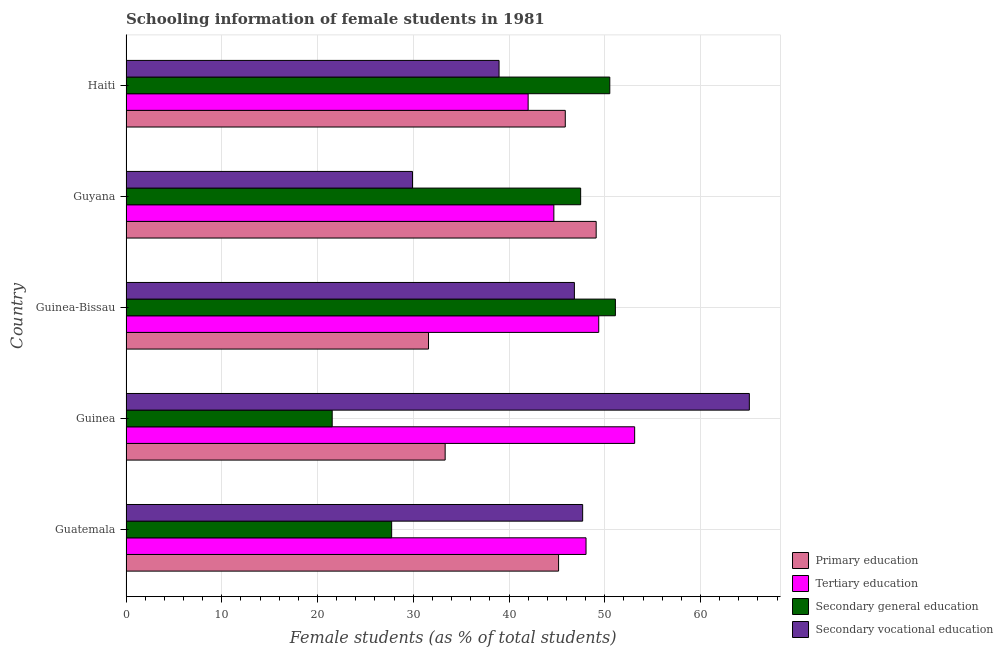How many groups of bars are there?
Provide a succinct answer. 5. Are the number of bars per tick equal to the number of legend labels?
Give a very brief answer. Yes. What is the label of the 5th group of bars from the top?
Provide a short and direct response. Guatemala. In how many cases, is the number of bars for a given country not equal to the number of legend labels?
Ensure brevity in your answer.  0. What is the percentage of female students in secondary education in Guinea-Bissau?
Your answer should be compact. 51.11. Across all countries, what is the maximum percentage of female students in primary education?
Make the answer very short. 49.1. Across all countries, what is the minimum percentage of female students in secondary education?
Provide a short and direct response. 21.53. In which country was the percentage of female students in tertiary education maximum?
Your answer should be compact. Guinea. In which country was the percentage of female students in secondary education minimum?
Your answer should be very brief. Guinea. What is the total percentage of female students in secondary vocational education in the graph?
Your response must be concise. 228.5. What is the difference between the percentage of female students in tertiary education in Guinea and that in Haiti?
Ensure brevity in your answer.  11.12. What is the difference between the percentage of female students in secondary vocational education in Guatemala and the percentage of female students in secondary education in Guinea?
Your response must be concise. 26.16. What is the average percentage of female students in secondary education per country?
Offer a very short reply. 39.68. What is the difference between the percentage of female students in secondary vocational education and percentage of female students in tertiary education in Guinea?
Offer a terse response. 11.98. What is the ratio of the percentage of female students in secondary vocational education in Guatemala to that in Haiti?
Provide a succinct answer. 1.22. Is the percentage of female students in secondary education in Guatemala less than that in Guinea-Bissau?
Give a very brief answer. Yes. What is the difference between the highest and the second highest percentage of female students in secondary vocational education?
Your answer should be very brief. 17.41. What is the difference between the highest and the lowest percentage of female students in tertiary education?
Provide a short and direct response. 11.13. Is it the case that in every country, the sum of the percentage of female students in secondary education and percentage of female students in primary education is greater than the sum of percentage of female students in secondary vocational education and percentage of female students in tertiary education?
Ensure brevity in your answer.  No. What does the 2nd bar from the top in Guatemala represents?
Offer a terse response. Secondary general education. What does the 4th bar from the bottom in Guatemala represents?
Your answer should be compact. Secondary vocational education. How many bars are there?
Offer a terse response. 20. Are the values on the major ticks of X-axis written in scientific E-notation?
Your response must be concise. No. Where does the legend appear in the graph?
Offer a terse response. Bottom right. How are the legend labels stacked?
Your answer should be very brief. Vertical. What is the title of the graph?
Provide a short and direct response. Schooling information of female students in 1981. What is the label or title of the X-axis?
Keep it short and to the point. Female students (as % of total students). What is the Female students (as % of total students) of Primary education in Guatemala?
Provide a succinct answer. 45.18. What is the Female students (as % of total students) in Tertiary education in Guatemala?
Offer a very short reply. 48.04. What is the Female students (as % of total students) of Secondary general education in Guatemala?
Ensure brevity in your answer.  27.74. What is the Female students (as % of total students) in Secondary vocational education in Guatemala?
Make the answer very short. 47.69. What is the Female students (as % of total students) of Primary education in Guinea?
Your response must be concise. 33.33. What is the Female students (as % of total students) of Tertiary education in Guinea?
Give a very brief answer. 53.12. What is the Female students (as % of total students) of Secondary general education in Guinea?
Your answer should be compact. 21.53. What is the Female students (as % of total students) in Secondary vocational education in Guinea?
Give a very brief answer. 65.1. What is the Female students (as % of total students) in Primary education in Guinea-Bissau?
Offer a terse response. 31.59. What is the Female students (as % of total students) of Tertiary education in Guinea-Bissau?
Offer a very short reply. 49.37. What is the Female students (as % of total students) of Secondary general education in Guinea-Bissau?
Offer a very short reply. 51.11. What is the Female students (as % of total students) of Secondary vocational education in Guinea-Bissau?
Keep it short and to the point. 46.83. What is the Female students (as % of total students) of Primary education in Guyana?
Give a very brief answer. 49.1. What is the Female students (as % of total students) of Tertiary education in Guyana?
Ensure brevity in your answer.  44.68. What is the Female students (as % of total students) of Secondary general education in Guyana?
Keep it short and to the point. 47.48. What is the Female students (as % of total students) of Secondary vocational education in Guyana?
Your answer should be compact. 29.92. What is the Female students (as % of total students) of Primary education in Haiti?
Make the answer very short. 45.88. What is the Female students (as % of total students) in Tertiary education in Haiti?
Your response must be concise. 42. What is the Female students (as % of total students) of Secondary general education in Haiti?
Offer a very short reply. 50.53. What is the Female students (as % of total students) in Secondary vocational education in Haiti?
Your answer should be very brief. 38.96. Across all countries, what is the maximum Female students (as % of total students) of Primary education?
Your response must be concise. 49.1. Across all countries, what is the maximum Female students (as % of total students) in Tertiary education?
Your response must be concise. 53.12. Across all countries, what is the maximum Female students (as % of total students) in Secondary general education?
Your answer should be compact. 51.11. Across all countries, what is the maximum Female students (as % of total students) in Secondary vocational education?
Your answer should be very brief. 65.1. Across all countries, what is the minimum Female students (as % of total students) of Primary education?
Make the answer very short. 31.59. Across all countries, what is the minimum Female students (as % of total students) of Tertiary education?
Your answer should be very brief. 42. Across all countries, what is the minimum Female students (as % of total students) of Secondary general education?
Give a very brief answer. 21.53. Across all countries, what is the minimum Female students (as % of total students) of Secondary vocational education?
Provide a succinct answer. 29.92. What is the total Female students (as % of total students) in Primary education in the graph?
Your response must be concise. 205.08. What is the total Female students (as % of total students) of Tertiary education in the graph?
Your answer should be very brief. 237.22. What is the total Female students (as % of total students) in Secondary general education in the graph?
Your answer should be very brief. 198.4. What is the total Female students (as % of total students) in Secondary vocational education in the graph?
Your answer should be compact. 228.5. What is the difference between the Female students (as % of total students) in Primary education in Guatemala and that in Guinea?
Provide a succinct answer. 11.85. What is the difference between the Female students (as % of total students) in Tertiary education in Guatemala and that in Guinea?
Give a very brief answer. -5.08. What is the difference between the Female students (as % of total students) in Secondary general education in Guatemala and that in Guinea?
Make the answer very short. 6.21. What is the difference between the Female students (as % of total students) in Secondary vocational education in Guatemala and that in Guinea?
Give a very brief answer. -17.41. What is the difference between the Female students (as % of total students) of Primary education in Guatemala and that in Guinea-Bissau?
Give a very brief answer. 13.58. What is the difference between the Female students (as % of total students) in Tertiary education in Guatemala and that in Guinea-Bissau?
Offer a terse response. -1.33. What is the difference between the Female students (as % of total students) in Secondary general education in Guatemala and that in Guinea-Bissau?
Make the answer very short. -23.37. What is the difference between the Female students (as % of total students) of Secondary vocational education in Guatemala and that in Guinea-Bissau?
Provide a succinct answer. 0.86. What is the difference between the Female students (as % of total students) of Primary education in Guatemala and that in Guyana?
Ensure brevity in your answer.  -3.93. What is the difference between the Female students (as % of total students) of Tertiary education in Guatemala and that in Guyana?
Provide a short and direct response. 3.36. What is the difference between the Female students (as % of total students) of Secondary general education in Guatemala and that in Guyana?
Ensure brevity in your answer.  -19.74. What is the difference between the Female students (as % of total students) of Secondary vocational education in Guatemala and that in Guyana?
Your response must be concise. 17.77. What is the difference between the Female students (as % of total students) of Primary education in Guatemala and that in Haiti?
Offer a very short reply. -0.7. What is the difference between the Female students (as % of total students) of Tertiary education in Guatemala and that in Haiti?
Provide a short and direct response. 6.05. What is the difference between the Female students (as % of total students) in Secondary general education in Guatemala and that in Haiti?
Provide a succinct answer. -22.78. What is the difference between the Female students (as % of total students) of Secondary vocational education in Guatemala and that in Haiti?
Your answer should be compact. 8.73. What is the difference between the Female students (as % of total students) of Primary education in Guinea and that in Guinea-Bissau?
Offer a terse response. 1.74. What is the difference between the Female students (as % of total students) in Tertiary education in Guinea and that in Guinea-Bissau?
Provide a short and direct response. 3.75. What is the difference between the Female students (as % of total students) in Secondary general education in Guinea and that in Guinea-Bissau?
Ensure brevity in your answer.  -29.58. What is the difference between the Female students (as % of total students) in Secondary vocational education in Guinea and that in Guinea-Bissau?
Offer a terse response. 18.27. What is the difference between the Female students (as % of total students) in Primary education in Guinea and that in Guyana?
Your response must be concise. -15.77. What is the difference between the Female students (as % of total students) in Tertiary education in Guinea and that in Guyana?
Offer a terse response. 8.44. What is the difference between the Female students (as % of total students) of Secondary general education in Guinea and that in Guyana?
Provide a succinct answer. -25.95. What is the difference between the Female students (as % of total students) of Secondary vocational education in Guinea and that in Guyana?
Keep it short and to the point. 35.18. What is the difference between the Female students (as % of total students) in Primary education in Guinea and that in Haiti?
Make the answer very short. -12.55. What is the difference between the Female students (as % of total students) of Tertiary education in Guinea and that in Haiti?
Provide a short and direct response. 11.12. What is the difference between the Female students (as % of total students) in Secondary general education in Guinea and that in Haiti?
Give a very brief answer. -28.99. What is the difference between the Female students (as % of total students) of Secondary vocational education in Guinea and that in Haiti?
Your answer should be very brief. 26.14. What is the difference between the Female students (as % of total students) of Primary education in Guinea-Bissau and that in Guyana?
Give a very brief answer. -17.51. What is the difference between the Female students (as % of total students) of Tertiary education in Guinea-Bissau and that in Guyana?
Provide a succinct answer. 4.69. What is the difference between the Female students (as % of total students) of Secondary general education in Guinea-Bissau and that in Guyana?
Provide a short and direct response. 3.63. What is the difference between the Female students (as % of total students) in Secondary vocational education in Guinea-Bissau and that in Guyana?
Give a very brief answer. 16.91. What is the difference between the Female students (as % of total students) in Primary education in Guinea-Bissau and that in Haiti?
Offer a terse response. -14.28. What is the difference between the Female students (as % of total students) of Tertiary education in Guinea-Bissau and that in Haiti?
Make the answer very short. 7.37. What is the difference between the Female students (as % of total students) in Secondary general education in Guinea-Bissau and that in Haiti?
Make the answer very short. 0.58. What is the difference between the Female students (as % of total students) in Secondary vocational education in Guinea-Bissau and that in Haiti?
Your answer should be very brief. 7.87. What is the difference between the Female students (as % of total students) in Primary education in Guyana and that in Haiti?
Ensure brevity in your answer.  3.23. What is the difference between the Female students (as % of total students) of Tertiary education in Guyana and that in Haiti?
Provide a short and direct response. 2.69. What is the difference between the Female students (as % of total students) of Secondary general education in Guyana and that in Haiti?
Give a very brief answer. -3.04. What is the difference between the Female students (as % of total students) in Secondary vocational education in Guyana and that in Haiti?
Make the answer very short. -9.04. What is the difference between the Female students (as % of total students) in Primary education in Guatemala and the Female students (as % of total students) in Tertiary education in Guinea?
Give a very brief answer. -7.95. What is the difference between the Female students (as % of total students) in Primary education in Guatemala and the Female students (as % of total students) in Secondary general education in Guinea?
Keep it short and to the point. 23.64. What is the difference between the Female students (as % of total students) of Primary education in Guatemala and the Female students (as % of total students) of Secondary vocational education in Guinea?
Offer a very short reply. -19.92. What is the difference between the Female students (as % of total students) in Tertiary education in Guatemala and the Female students (as % of total students) in Secondary general education in Guinea?
Provide a short and direct response. 26.51. What is the difference between the Female students (as % of total students) in Tertiary education in Guatemala and the Female students (as % of total students) in Secondary vocational education in Guinea?
Your answer should be very brief. -17.06. What is the difference between the Female students (as % of total students) of Secondary general education in Guatemala and the Female students (as % of total students) of Secondary vocational education in Guinea?
Your answer should be compact. -37.36. What is the difference between the Female students (as % of total students) in Primary education in Guatemala and the Female students (as % of total students) in Tertiary education in Guinea-Bissau?
Offer a terse response. -4.19. What is the difference between the Female students (as % of total students) of Primary education in Guatemala and the Female students (as % of total students) of Secondary general education in Guinea-Bissau?
Your response must be concise. -5.93. What is the difference between the Female students (as % of total students) of Primary education in Guatemala and the Female students (as % of total students) of Secondary vocational education in Guinea-Bissau?
Give a very brief answer. -1.65. What is the difference between the Female students (as % of total students) of Tertiary education in Guatemala and the Female students (as % of total students) of Secondary general education in Guinea-Bissau?
Your response must be concise. -3.07. What is the difference between the Female students (as % of total students) of Tertiary education in Guatemala and the Female students (as % of total students) of Secondary vocational education in Guinea-Bissau?
Keep it short and to the point. 1.22. What is the difference between the Female students (as % of total students) of Secondary general education in Guatemala and the Female students (as % of total students) of Secondary vocational education in Guinea-Bissau?
Keep it short and to the point. -19.08. What is the difference between the Female students (as % of total students) in Primary education in Guatemala and the Female students (as % of total students) in Tertiary education in Guyana?
Offer a terse response. 0.49. What is the difference between the Female students (as % of total students) of Primary education in Guatemala and the Female students (as % of total students) of Secondary general education in Guyana?
Your answer should be compact. -2.31. What is the difference between the Female students (as % of total students) in Primary education in Guatemala and the Female students (as % of total students) in Secondary vocational education in Guyana?
Ensure brevity in your answer.  15.26. What is the difference between the Female students (as % of total students) of Tertiary education in Guatemala and the Female students (as % of total students) of Secondary general education in Guyana?
Your response must be concise. 0.56. What is the difference between the Female students (as % of total students) of Tertiary education in Guatemala and the Female students (as % of total students) of Secondary vocational education in Guyana?
Your answer should be very brief. 18.12. What is the difference between the Female students (as % of total students) in Secondary general education in Guatemala and the Female students (as % of total students) in Secondary vocational education in Guyana?
Keep it short and to the point. -2.18. What is the difference between the Female students (as % of total students) of Primary education in Guatemala and the Female students (as % of total students) of Tertiary education in Haiti?
Offer a very short reply. 3.18. What is the difference between the Female students (as % of total students) of Primary education in Guatemala and the Female students (as % of total students) of Secondary general education in Haiti?
Your answer should be very brief. -5.35. What is the difference between the Female students (as % of total students) in Primary education in Guatemala and the Female students (as % of total students) in Secondary vocational education in Haiti?
Keep it short and to the point. 6.21. What is the difference between the Female students (as % of total students) in Tertiary education in Guatemala and the Female students (as % of total students) in Secondary general education in Haiti?
Give a very brief answer. -2.48. What is the difference between the Female students (as % of total students) in Tertiary education in Guatemala and the Female students (as % of total students) in Secondary vocational education in Haiti?
Your response must be concise. 9.08. What is the difference between the Female students (as % of total students) in Secondary general education in Guatemala and the Female students (as % of total students) in Secondary vocational education in Haiti?
Your answer should be compact. -11.22. What is the difference between the Female students (as % of total students) of Primary education in Guinea and the Female students (as % of total students) of Tertiary education in Guinea-Bissau?
Provide a succinct answer. -16.04. What is the difference between the Female students (as % of total students) in Primary education in Guinea and the Female students (as % of total students) in Secondary general education in Guinea-Bissau?
Provide a short and direct response. -17.78. What is the difference between the Female students (as % of total students) of Primary education in Guinea and the Female students (as % of total students) of Secondary vocational education in Guinea-Bissau?
Provide a succinct answer. -13.5. What is the difference between the Female students (as % of total students) in Tertiary education in Guinea and the Female students (as % of total students) in Secondary general education in Guinea-Bissau?
Your answer should be very brief. 2.01. What is the difference between the Female students (as % of total students) of Tertiary education in Guinea and the Female students (as % of total students) of Secondary vocational education in Guinea-Bissau?
Make the answer very short. 6.29. What is the difference between the Female students (as % of total students) in Secondary general education in Guinea and the Female students (as % of total students) in Secondary vocational education in Guinea-Bissau?
Keep it short and to the point. -25.29. What is the difference between the Female students (as % of total students) of Primary education in Guinea and the Female students (as % of total students) of Tertiary education in Guyana?
Ensure brevity in your answer.  -11.35. What is the difference between the Female students (as % of total students) of Primary education in Guinea and the Female students (as % of total students) of Secondary general education in Guyana?
Provide a succinct answer. -14.15. What is the difference between the Female students (as % of total students) of Primary education in Guinea and the Female students (as % of total students) of Secondary vocational education in Guyana?
Give a very brief answer. 3.41. What is the difference between the Female students (as % of total students) in Tertiary education in Guinea and the Female students (as % of total students) in Secondary general education in Guyana?
Your response must be concise. 5.64. What is the difference between the Female students (as % of total students) of Tertiary education in Guinea and the Female students (as % of total students) of Secondary vocational education in Guyana?
Provide a succinct answer. 23.2. What is the difference between the Female students (as % of total students) in Secondary general education in Guinea and the Female students (as % of total students) in Secondary vocational education in Guyana?
Your answer should be compact. -8.39. What is the difference between the Female students (as % of total students) of Primary education in Guinea and the Female students (as % of total students) of Tertiary education in Haiti?
Make the answer very short. -8.67. What is the difference between the Female students (as % of total students) in Primary education in Guinea and the Female students (as % of total students) in Secondary general education in Haiti?
Ensure brevity in your answer.  -17.2. What is the difference between the Female students (as % of total students) of Primary education in Guinea and the Female students (as % of total students) of Secondary vocational education in Haiti?
Give a very brief answer. -5.63. What is the difference between the Female students (as % of total students) of Tertiary education in Guinea and the Female students (as % of total students) of Secondary general education in Haiti?
Your answer should be very brief. 2.6. What is the difference between the Female students (as % of total students) in Tertiary education in Guinea and the Female students (as % of total students) in Secondary vocational education in Haiti?
Your answer should be compact. 14.16. What is the difference between the Female students (as % of total students) in Secondary general education in Guinea and the Female students (as % of total students) in Secondary vocational education in Haiti?
Offer a very short reply. -17.43. What is the difference between the Female students (as % of total students) of Primary education in Guinea-Bissau and the Female students (as % of total students) of Tertiary education in Guyana?
Provide a succinct answer. -13.09. What is the difference between the Female students (as % of total students) of Primary education in Guinea-Bissau and the Female students (as % of total students) of Secondary general education in Guyana?
Make the answer very short. -15.89. What is the difference between the Female students (as % of total students) in Primary education in Guinea-Bissau and the Female students (as % of total students) in Secondary vocational education in Guyana?
Provide a short and direct response. 1.67. What is the difference between the Female students (as % of total students) of Tertiary education in Guinea-Bissau and the Female students (as % of total students) of Secondary general education in Guyana?
Your answer should be very brief. 1.89. What is the difference between the Female students (as % of total students) of Tertiary education in Guinea-Bissau and the Female students (as % of total students) of Secondary vocational education in Guyana?
Provide a succinct answer. 19.45. What is the difference between the Female students (as % of total students) in Secondary general education in Guinea-Bissau and the Female students (as % of total students) in Secondary vocational education in Guyana?
Ensure brevity in your answer.  21.19. What is the difference between the Female students (as % of total students) of Primary education in Guinea-Bissau and the Female students (as % of total students) of Tertiary education in Haiti?
Make the answer very short. -10.4. What is the difference between the Female students (as % of total students) of Primary education in Guinea-Bissau and the Female students (as % of total students) of Secondary general education in Haiti?
Provide a succinct answer. -18.93. What is the difference between the Female students (as % of total students) of Primary education in Guinea-Bissau and the Female students (as % of total students) of Secondary vocational education in Haiti?
Provide a succinct answer. -7.37. What is the difference between the Female students (as % of total students) in Tertiary education in Guinea-Bissau and the Female students (as % of total students) in Secondary general education in Haiti?
Offer a terse response. -1.16. What is the difference between the Female students (as % of total students) of Tertiary education in Guinea-Bissau and the Female students (as % of total students) of Secondary vocational education in Haiti?
Ensure brevity in your answer.  10.41. What is the difference between the Female students (as % of total students) of Secondary general education in Guinea-Bissau and the Female students (as % of total students) of Secondary vocational education in Haiti?
Provide a short and direct response. 12.15. What is the difference between the Female students (as % of total students) in Primary education in Guyana and the Female students (as % of total students) in Tertiary education in Haiti?
Your answer should be very brief. 7.1. What is the difference between the Female students (as % of total students) in Primary education in Guyana and the Female students (as % of total students) in Secondary general education in Haiti?
Offer a very short reply. -1.42. What is the difference between the Female students (as % of total students) of Primary education in Guyana and the Female students (as % of total students) of Secondary vocational education in Haiti?
Your answer should be compact. 10.14. What is the difference between the Female students (as % of total students) of Tertiary education in Guyana and the Female students (as % of total students) of Secondary general education in Haiti?
Your answer should be compact. -5.84. What is the difference between the Female students (as % of total students) in Tertiary education in Guyana and the Female students (as % of total students) in Secondary vocational education in Haiti?
Your answer should be very brief. 5.72. What is the difference between the Female students (as % of total students) in Secondary general education in Guyana and the Female students (as % of total students) in Secondary vocational education in Haiti?
Your answer should be compact. 8.52. What is the average Female students (as % of total students) in Primary education per country?
Give a very brief answer. 41.02. What is the average Female students (as % of total students) of Tertiary education per country?
Provide a succinct answer. 47.44. What is the average Female students (as % of total students) in Secondary general education per country?
Keep it short and to the point. 39.68. What is the average Female students (as % of total students) in Secondary vocational education per country?
Provide a succinct answer. 45.7. What is the difference between the Female students (as % of total students) of Primary education and Female students (as % of total students) of Tertiary education in Guatemala?
Provide a short and direct response. -2.87. What is the difference between the Female students (as % of total students) in Primary education and Female students (as % of total students) in Secondary general education in Guatemala?
Your response must be concise. 17.43. What is the difference between the Female students (as % of total students) in Primary education and Female students (as % of total students) in Secondary vocational education in Guatemala?
Give a very brief answer. -2.52. What is the difference between the Female students (as % of total students) of Tertiary education and Female students (as % of total students) of Secondary general education in Guatemala?
Provide a short and direct response. 20.3. What is the difference between the Female students (as % of total students) of Tertiary education and Female students (as % of total students) of Secondary vocational education in Guatemala?
Give a very brief answer. 0.35. What is the difference between the Female students (as % of total students) in Secondary general education and Female students (as % of total students) in Secondary vocational education in Guatemala?
Your response must be concise. -19.95. What is the difference between the Female students (as % of total students) in Primary education and Female students (as % of total students) in Tertiary education in Guinea?
Your response must be concise. -19.79. What is the difference between the Female students (as % of total students) of Primary education and Female students (as % of total students) of Secondary general education in Guinea?
Your answer should be very brief. 11.8. What is the difference between the Female students (as % of total students) in Primary education and Female students (as % of total students) in Secondary vocational education in Guinea?
Your answer should be very brief. -31.77. What is the difference between the Female students (as % of total students) of Tertiary education and Female students (as % of total students) of Secondary general education in Guinea?
Ensure brevity in your answer.  31.59. What is the difference between the Female students (as % of total students) of Tertiary education and Female students (as % of total students) of Secondary vocational education in Guinea?
Offer a very short reply. -11.98. What is the difference between the Female students (as % of total students) of Secondary general education and Female students (as % of total students) of Secondary vocational education in Guinea?
Offer a terse response. -43.57. What is the difference between the Female students (as % of total students) of Primary education and Female students (as % of total students) of Tertiary education in Guinea-Bissau?
Offer a terse response. -17.78. What is the difference between the Female students (as % of total students) in Primary education and Female students (as % of total students) in Secondary general education in Guinea-Bissau?
Give a very brief answer. -19.52. What is the difference between the Female students (as % of total students) of Primary education and Female students (as % of total students) of Secondary vocational education in Guinea-Bissau?
Ensure brevity in your answer.  -15.24. What is the difference between the Female students (as % of total students) in Tertiary education and Female students (as % of total students) in Secondary general education in Guinea-Bissau?
Keep it short and to the point. -1.74. What is the difference between the Female students (as % of total students) of Tertiary education and Female students (as % of total students) of Secondary vocational education in Guinea-Bissau?
Your answer should be compact. 2.54. What is the difference between the Female students (as % of total students) in Secondary general education and Female students (as % of total students) in Secondary vocational education in Guinea-Bissau?
Your answer should be compact. 4.28. What is the difference between the Female students (as % of total students) in Primary education and Female students (as % of total students) in Tertiary education in Guyana?
Provide a succinct answer. 4.42. What is the difference between the Female students (as % of total students) in Primary education and Female students (as % of total students) in Secondary general education in Guyana?
Provide a short and direct response. 1.62. What is the difference between the Female students (as % of total students) of Primary education and Female students (as % of total students) of Secondary vocational education in Guyana?
Keep it short and to the point. 19.18. What is the difference between the Female students (as % of total students) in Tertiary education and Female students (as % of total students) in Secondary vocational education in Guyana?
Give a very brief answer. 14.76. What is the difference between the Female students (as % of total students) in Secondary general education and Female students (as % of total students) in Secondary vocational education in Guyana?
Ensure brevity in your answer.  17.56. What is the difference between the Female students (as % of total students) in Primary education and Female students (as % of total students) in Tertiary education in Haiti?
Your answer should be very brief. 3.88. What is the difference between the Female students (as % of total students) of Primary education and Female students (as % of total students) of Secondary general education in Haiti?
Make the answer very short. -4.65. What is the difference between the Female students (as % of total students) in Primary education and Female students (as % of total students) in Secondary vocational education in Haiti?
Provide a succinct answer. 6.92. What is the difference between the Female students (as % of total students) of Tertiary education and Female students (as % of total students) of Secondary general education in Haiti?
Offer a very short reply. -8.53. What is the difference between the Female students (as % of total students) in Tertiary education and Female students (as % of total students) in Secondary vocational education in Haiti?
Provide a succinct answer. 3.04. What is the difference between the Female students (as % of total students) in Secondary general education and Female students (as % of total students) in Secondary vocational education in Haiti?
Provide a short and direct response. 11.56. What is the ratio of the Female students (as % of total students) of Primary education in Guatemala to that in Guinea?
Keep it short and to the point. 1.36. What is the ratio of the Female students (as % of total students) in Tertiary education in Guatemala to that in Guinea?
Ensure brevity in your answer.  0.9. What is the ratio of the Female students (as % of total students) of Secondary general education in Guatemala to that in Guinea?
Offer a very short reply. 1.29. What is the ratio of the Female students (as % of total students) in Secondary vocational education in Guatemala to that in Guinea?
Your answer should be compact. 0.73. What is the ratio of the Female students (as % of total students) in Primary education in Guatemala to that in Guinea-Bissau?
Keep it short and to the point. 1.43. What is the ratio of the Female students (as % of total students) of Tertiary education in Guatemala to that in Guinea-Bissau?
Your answer should be very brief. 0.97. What is the ratio of the Female students (as % of total students) of Secondary general education in Guatemala to that in Guinea-Bissau?
Your answer should be very brief. 0.54. What is the ratio of the Female students (as % of total students) of Secondary vocational education in Guatemala to that in Guinea-Bissau?
Give a very brief answer. 1.02. What is the ratio of the Female students (as % of total students) in Primary education in Guatemala to that in Guyana?
Provide a succinct answer. 0.92. What is the ratio of the Female students (as % of total students) in Tertiary education in Guatemala to that in Guyana?
Provide a succinct answer. 1.08. What is the ratio of the Female students (as % of total students) in Secondary general education in Guatemala to that in Guyana?
Make the answer very short. 0.58. What is the ratio of the Female students (as % of total students) of Secondary vocational education in Guatemala to that in Guyana?
Keep it short and to the point. 1.59. What is the ratio of the Female students (as % of total students) in Primary education in Guatemala to that in Haiti?
Your answer should be very brief. 0.98. What is the ratio of the Female students (as % of total students) in Tertiary education in Guatemala to that in Haiti?
Your answer should be very brief. 1.14. What is the ratio of the Female students (as % of total students) of Secondary general education in Guatemala to that in Haiti?
Ensure brevity in your answer.  0.55. What is the ratio of the Female students (as % of total students) of Secondary vocational education in Guatemala to that in Haiti?
Ensure brevity in your answer.  1.22. What is the ratio of the Female students (as % of total students) in Primary education in Guinea to that in Guinea-Bissau?
Your answer should be very brief. 1.05. What is the ratio of the Female students (as % of total students) of Tertiary education in Guinea to that in Guinea-Bissau?
Offer a terse response. 1.08. What is the ratio of the Female students (as % of total students) of Secondary general education in Guinea to that in Guinea-Bissau?
Give a very brief answer. 0.42. What is the ratio of the Female students (as % of total students) in Secondary vocational education in Guinea to that in Guinea-Bissau?
Your answer should be compact. 1.39. What is the ratio of the Female students (as % of total students) of Primary education in Guinea to that in Guyana?
Offer a very short reply. 0.68. What is the ratio of the Female students (as % of total students) of Tertiary education in Guinea to that in Guyana?
Your response must be concise. 1.19. What is the ratio of the Female students (as % of total students) in Secondary general education in Guinea to that in Guyana?
Keep it short and to the point. 0.45. What is the ratio of the Female students (as % of total students) of Secondary vocational education in Guinea to that in Guyana?
Provide a short and direct response. 2.18. What is the ratio of the Female students (as % of total students) in Primary education in Guinea to that in Haiti?
Offer a very short reply. 0.73. What is the ratio of the Female students (as % of total students) of Tertiary education in Guinea to that in Haiti?
Your response must be concise. 1.26. What is the ratio of the Female students (as % of total students) of Secondary general education in Guinea to that in Haiti?
Give a very brief answer. 0.43. What is the ratio of the Female students (as % of total students) of Secondary vocational education in Guinea to that in Haiti?
Keep it short and to the point. 1.67. What is the ratio of the Female students (as % of total students) in Primary education in Guinea-Bissau to that in Guyana?
Make the answer very short. 0.64. What is the ratio of the Female students (as % of total students) of Tertiary education in Guinea-Bissau to that in Guyana?
Give a very brief answer. 1.1. What is the ratio of the Female students (as % of total students) of Secondary general education in Guinea-Bissau to that in Guyana?
Give a very brief answer. 1.08. What is the ratio of the Female students (as % of total students) in Secondary vocational education in Guinea-Bissau to that in Guyana?
Make the answer very short. 1.57. What is the ratio of the Female students (as % of total students) of Primary education in Guinea-Bissau to that in Haiti?
Give a very brief answer. 0.69. What is the ratio of the Female students (as % of total students) of Tertiary education in Guinea-Bissau to that in Haiti?
Your answer should be very brief. 1.18. What is the ratio of the Female students (as % of total students) of Secondary general education in Guinea-Bissau to that in Haiti?
Your answer should be very brief. 1.01. What is the ratio of the Female students (as % of total students) of Secondary vocational education in Guinea-Bissau to that in Haiti?
Your answer should be compact. 1.2. What is the ratio of the Female students (as % of total students) of Primary education in Guyana to that in Haiti?
Your response must be concise. 1.07. What is the ratio of the Female students (as % of total students) of Tertiary education in Guyana to that in Haiti?
Your answer should be very brief. 1.06. What is the ratio of the Female students (as % of total students) of Secondary general education in Guyana to that in Haiti?
Offer a very short reply. 0.94. What is the ratio of the Female students (as % of total students) of Secondary vocational education in Guyana to that in Haiti?
Your answer should be compact. 0.77. What is the difference between the highest and the second highest Female students (as % of total students) in Primary education?
Your answer should be very brief. 3.23. What is the difference between the highest and the second highest Female students (as % of total students) of Tertiary education?
Provide a short and direct response. 3.75. What is the difference between the highest and the second highest Female students (as % of total students) of Secondary general education?
Your answer should be compact. 0.58. What is the difference between the highest and the second highest Female students (as % of total students) in Secondary vocational education?
Your answer should be compact. 17.41. What is the difference between the highest and the lowest Female students (as % of total students) of Primary education?
Offer a terse response. 17.51. What is the difference between the highest and the lowest Female students (as % of total students) of Tertiary education?
Your response must be concise. 11.12. What is the difference between the highest and the lowest Female students (as % of total students) of Secondary general education?
Offer a terse response. 29.58. What is the difference between the highest and the lowest Female students (as % of total students) in Secondary vocational education?
Give a very brief answer. 35.18. 